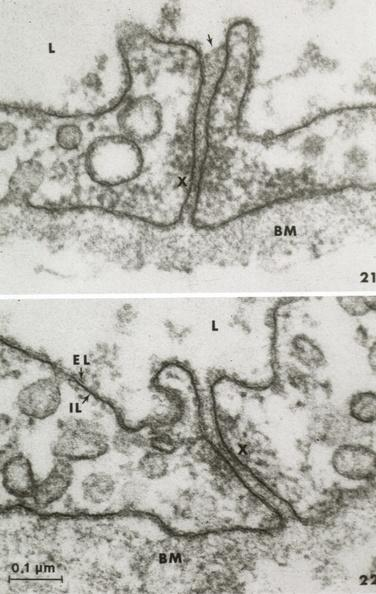what is present?
Answer the question using a single word or phrase. Cardiovascular 